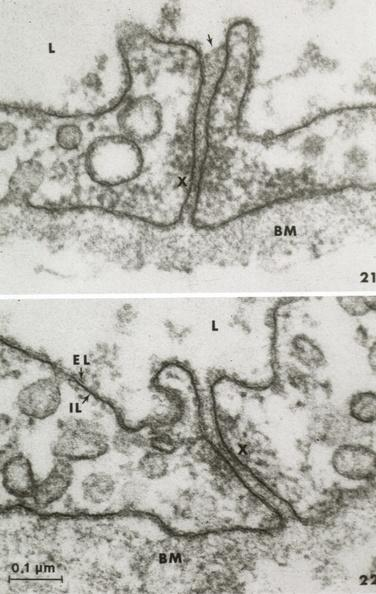what is present?
Answer the question using a single word or phrase. Cardiovascular 